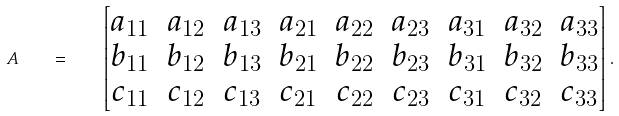Convert formula to latex. <formula><loc_0><loc_0><loc_500><loc_500>A \quad = \quad \begin{bmatrix} a _ { 1 1 } & a _ { 1 2 } & a _ { 1 3 } & a _ { 2 1 } & a _ { 2 2 } & a _ { 2 3 } & a _ { 3 1 } & a _ { 3 2 } & a _ { 3 3 } \\ b _ { 1 1 } & b _ { 1 2 } & b _ { 1 3 } & b _ { 2 1 } & b _ { 2 2 } & b _ { 2 3 } & b _ { 3 1 } & b _ { 3 2 } & b _ { 3 3 } \\ c _ { 1 1 } & c _ { 1 2 } & c _ { 1 3 } & c _ { 2 1 } & c _ { 2 2 } & c _ { 2 3 } & c _ { 3 1 } & c _ { 3 2 } & c _ { 3 3 } \end{bmatrix} .</formula> 